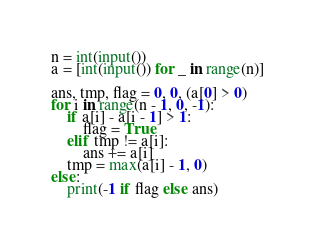<code> <loc_0><loc_0><loc_500><loc_500><_Python_>n = int(input())
a = [int(input()) for _ in range(n)]

ans, tmp, flag = 0, 0, (a[0] > 0)
for i in range(n - 1, 0, -1):
    if a[i] - a[i - 1] > 1:
        flag = True
    elif tmp != a[i]:
        ans += a[i]
    tmp = max(a[i] - 1, 0)
else:
    print(-1 if flag else ans)
</code> 